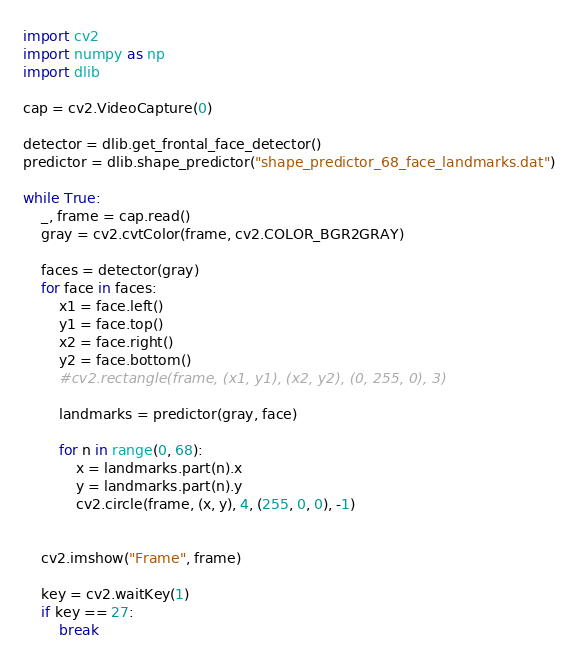<code> <loc_0><loc_0><loc_500><loc_500><_Python_>import cv2
import numpy as np
import dlib

cap = cv2.VideoCapture(0)

detector = dlib.get_frontal_face_detector()
predictor = dlib.shape_predictor("shape_predictor_68_face_landmarks.dat")

while True:
    _, frame = cap.read()
    gray = cv2.cvtColor(frame, cv2.COLOR_BGR2GRAY)

    faces = detector(gray)
    for face in faces:
        x1 = face.left()
        y1 = face.top()
        x2 = face.right()
        y2 = face.bottom()
        #cv2.rectangle(frame, (x1, y1), (x2, y2), (0, 255, 0), 3)

        landmarks = predictor(gray, face)

        for n in range(0, 68):
            x = landmarks.part(n).x
            y = landmarks.part(n).y
            cv2.circle(frame, (x, y), 4, (255, 0, 0), -1)


    cv2.imshow("Frame", frame)

    key = cv2.waitKey(1)
    if key == 27:
        break</code> 